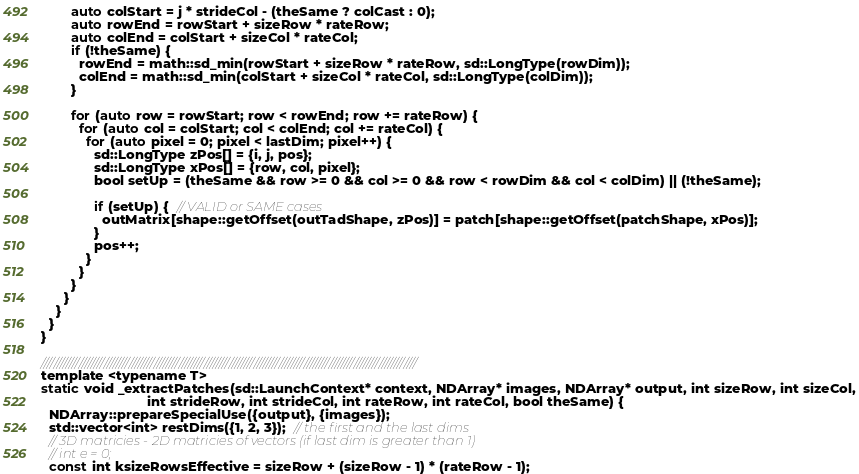<code> <loc_0><loc_0><loc_500><loc_500><_Cuda_>        auto colStart = j * strideCol - (theSame ? colCast : 0);
        auto rowEnd = rowStart + sizeRow * rateRow;
        auto colEnd = colStart + sizeCol * rateCol;
        if (!theSame) {
          rowEnd = math::sd_min(rowStart + sizeRow * rateRow, sd::LongType(rowDim));
          colEnd = math::sd_min(colStart + sizeCol * rateCol, sd::LongType(colDim));
        }

        for (auto row = rowStart; row < rowEnd; row += rateRow) {
          for (auto col = colStart; col < colEnd; col += rateCol) {
            for (auto pixel = 0; pixel < lastDim; pixel++) {
              sd::LongType zPos[] = {i, j, pos};
              sd::LongType xPos[] = {row, col, pixel};
              bool setUp = (theSame && row >= 0 && col >= 0 && row < rowDim && col < colDim) || (!theSame);

              if (setUp) {  // VALID or SAME cases
                outMatrix[shape::getOffset(outTadShape, zPos)] = patch[shape::getOffset(patchShape, xPos)];
              }
              pos++;
            }
          }
        }
      }
    }
  }
}

////////////////////////////////////////////////////////////////////////////////////////////////////////////////////////
template <typename T>
static void _extractPatches(sd::LaunchContext* context, NDArray* images, NDArray* output, int sizeRow, int sizeCol,
                            int strideRow, int strideCol, int rateRow, int rateCol, bool theSame) {
  NDArray::prepareSpecialUse({output}, {images});
  std::vector<int> restDims({1, 2, 3});  // the first and the last dims
  // 3D matricies - 2D matricies of vectors (if last dim is greater than 1)
  // int e = 0;
  const int ksizeRowsEffective = sizeRow + (sizeRow - 1) * (rateRow - 1);</code> 